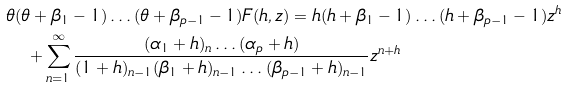<formula> <loc_0><loc_0><loc_500><loc_500>& \theta ( \theta + \beta _ { 1 } - 1 ) \dots ( \theta + \beta _ { p - 1 } - 1 ) F ( h , z ) = h ( h + \beta _ { 1 } - 1 ) \dots ( h + \beta _ { p - 1 } - 1 ) z ^ { h } \\ & \quad + \sum _ { n = 1 } ^ { \infty } \frac { ( \alpha _ { 1 } + h ) _ { n } \dots ( \alpha _ { p } + h ) } { ( 1 + h ) _ { n - 1 } ( \beta _ { 1 } + h ) _ { n - 1 } \dots ( \beta _ { p - 1 } + h ) _ { n - 1 } } z ^ { n + h }</formula> 